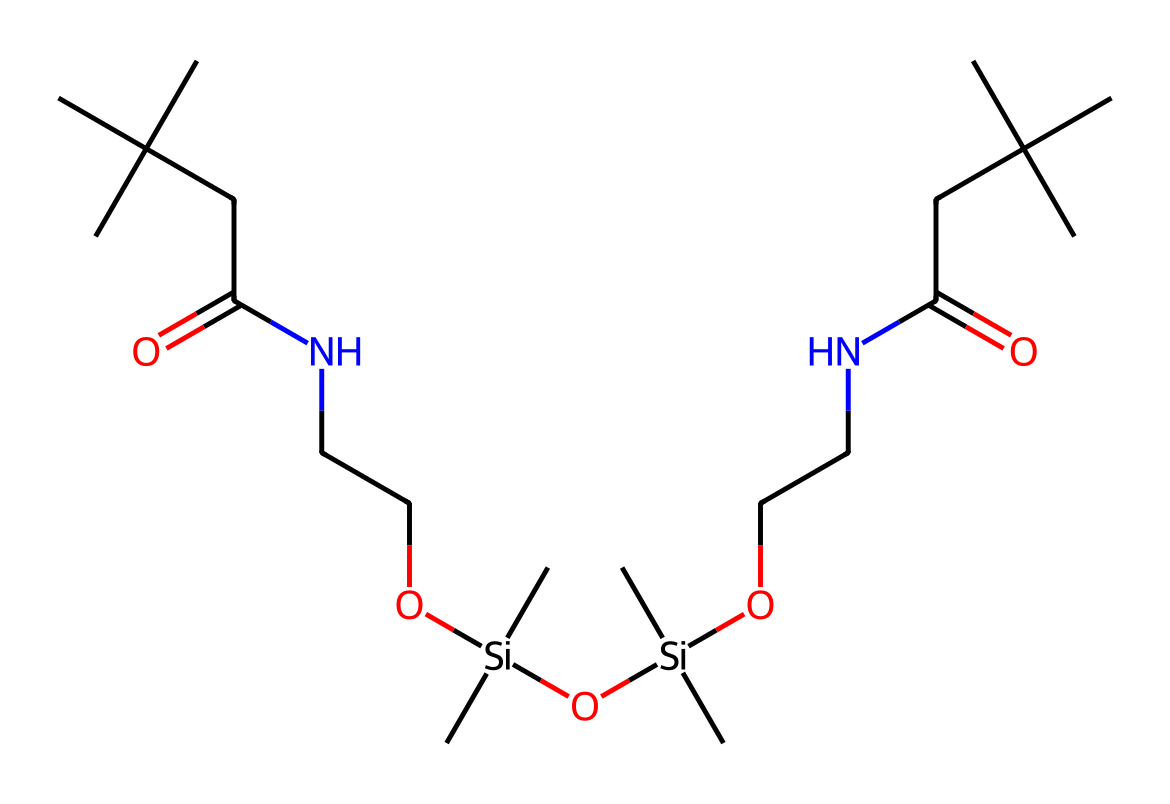what is the molecular formula of this chemical? To determine the molecular formula, we need to identify the individual atoms present in the structure. From the SMILES representation, we can count the carbon (C), hydrogen (H), nitrogen (N), oxygen (O), and silicon (Si) atoms. The counting gives us C22, H45, N3, O5, Si2. Therefore, the molecular formula is C22H45N3O5Si2.
Answer: C22H45N3O5Si2 how many nitrogen atoms are present in this chemical? By analyzing the SMILES representation, we count the number of nitrogen (N) atoms in the structure. The representation indicates there are three nitrogen atoms present.
Answer: 3 which functional groups are present in this polymer? Functional groups introduce specific chemical reactivity and properties. In the structure, we identify the amine (-NH), amide (-CONH-), and silanol (-Si-OH) as key functional groups present.
Answer: amine, amide, silanol how many silicon atoms are included in the structure? To find the number of silicon (Si) atoms, we can scan through the SMILES representation and specifically count instances of the silicon atom. The chemical contains two silicon atoms.
Answer: 2 what type of polymer is represented by this chemical? The polymer in the chemical structure is a type of polyurethane. Polyurethanes are formed through the reaction of diisocyanates and alcohols or polyols, which is indicated in the SMILES by the presence of amine and amide linkages.
Answer: polyurethane what is the significance of the silanol groups in this composition? Silanol groups (-Si-OH) enhance the material's surface properties, offering improved adhesion, flexibility, and water resistance. These attributes are important for gym mats and equipment padding, contributing to their durability and performance.
Answer: surface properties, adhesion, flexibility describe the role of the carbon chain length in this polymer's properties. The length of the carbon chains affects the mechanical properties, such as flexibility and resilience of the polymer. Longer carbon chains generally lead to increased toughness while enabling the material to absorb impact, essential for gym mats and padding.
Answer: impact absorption, toughness 